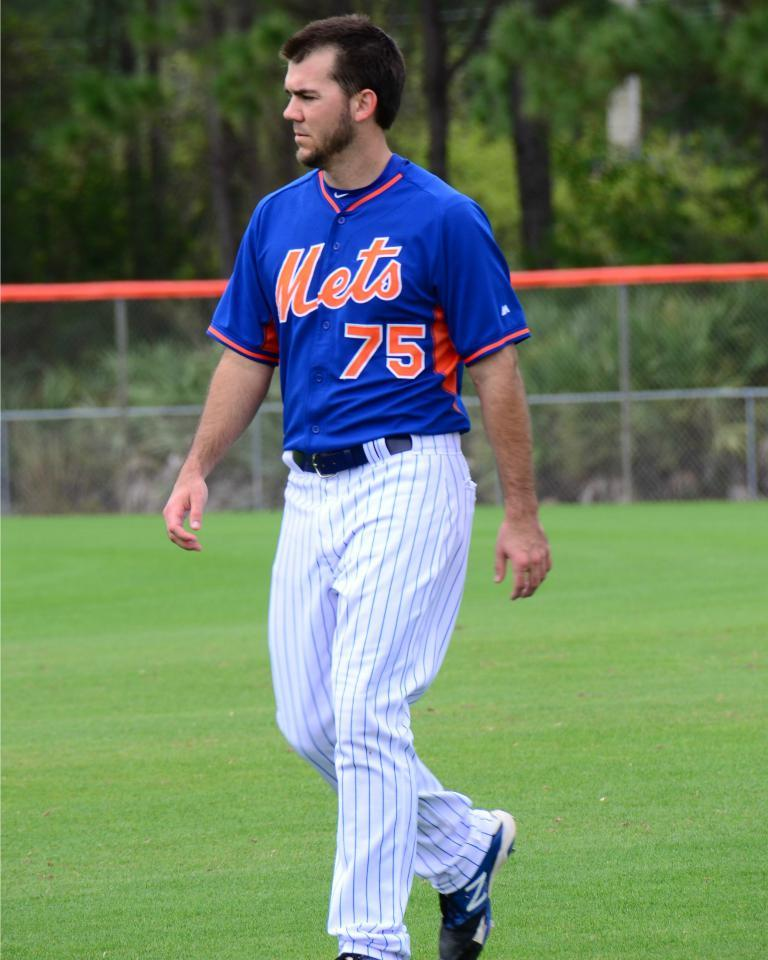<image>
Relay a brief, clear account of the picture shown. A Mets player walks across the field without a glove on. 